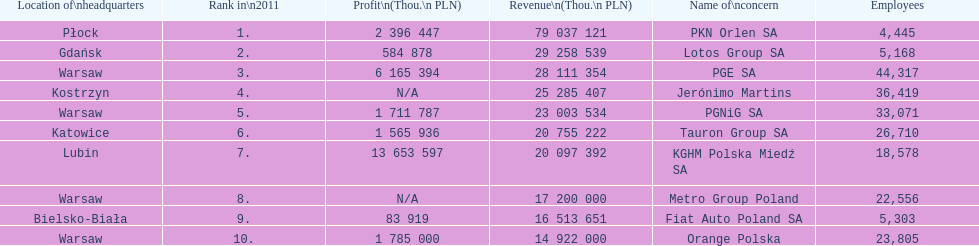How many companies had over $1,000,000 profit? 6. 